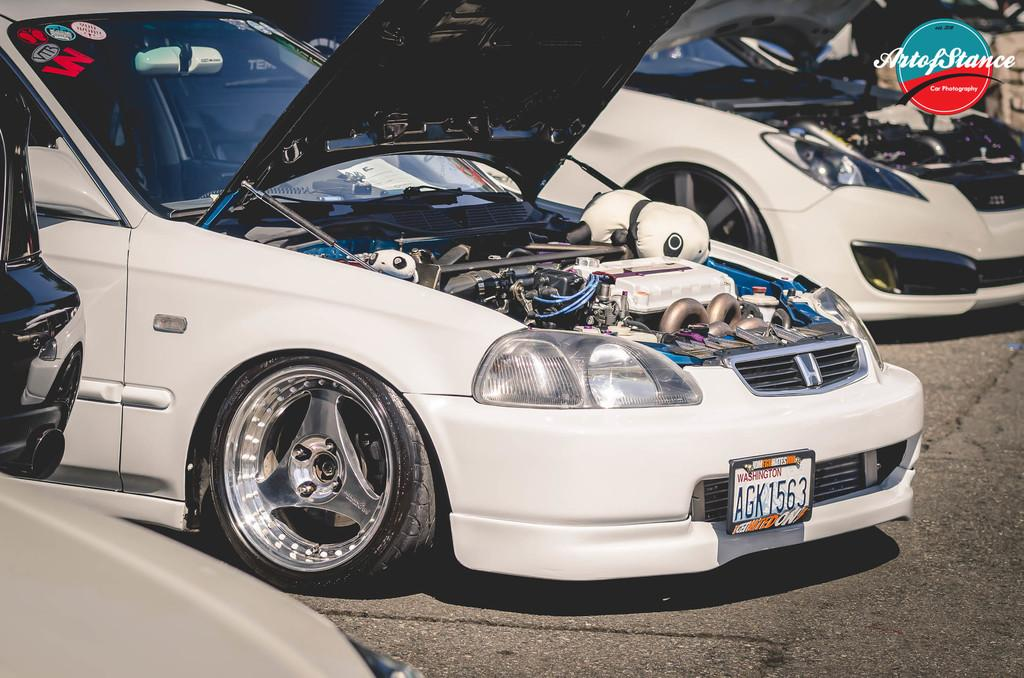What type of objects are present in the image? There are vehicles in the image. What is the state of the vehicles? The vehicles are opened. What can be seen inside the vehicles? Engines are visible in the image. What is the setting of the image? There is a road at the bottom of the image. Where are the sisters standing in the image? There are no sisters present in the image. What type of curtain can be seen hanging in the vehicles? There are no curtains visible in the image; only engines are present inside the vehicles. 